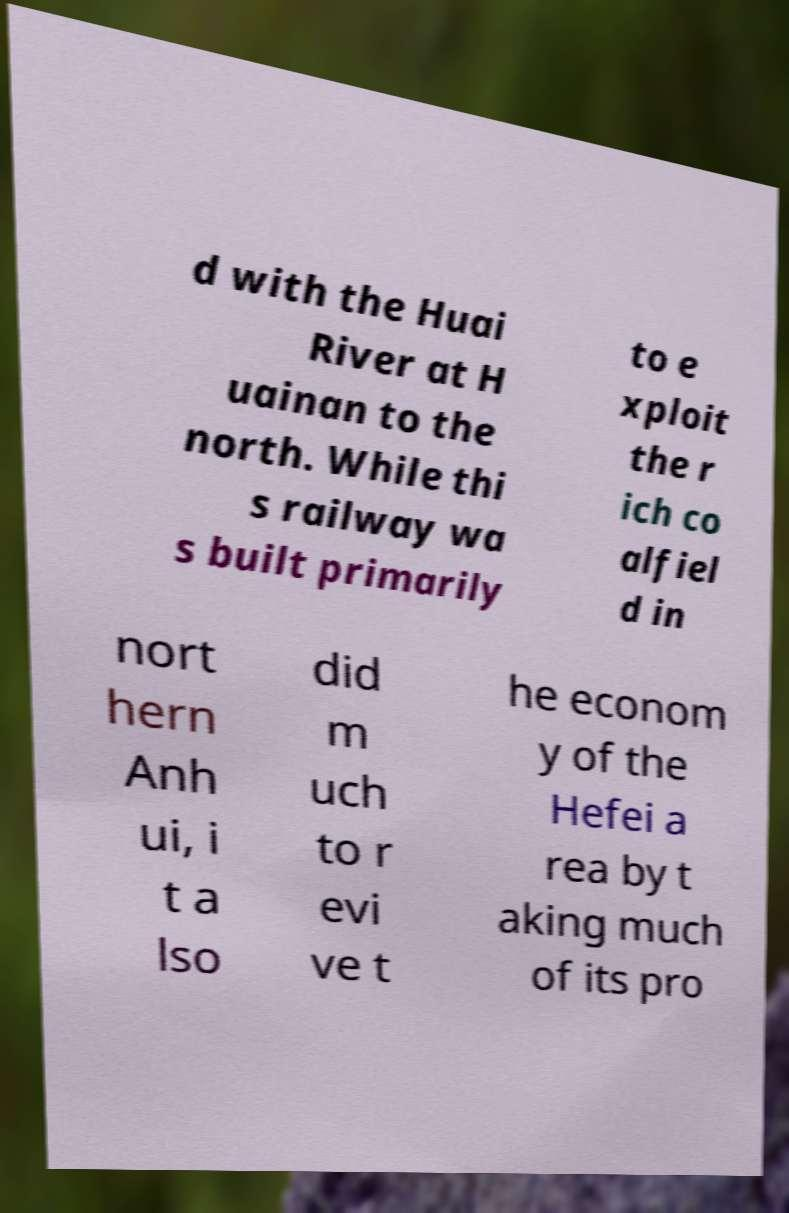Could you extract and type out the text from this image? d with the Huai River at H uainan to the north. While thi s railway wa s built primarily to e xploit the r ich co alfiel d in nort hern Anh ui, i t a lso did m uch to r evi ve t he econom y of the Hefei a rea by t aking much of its pro 